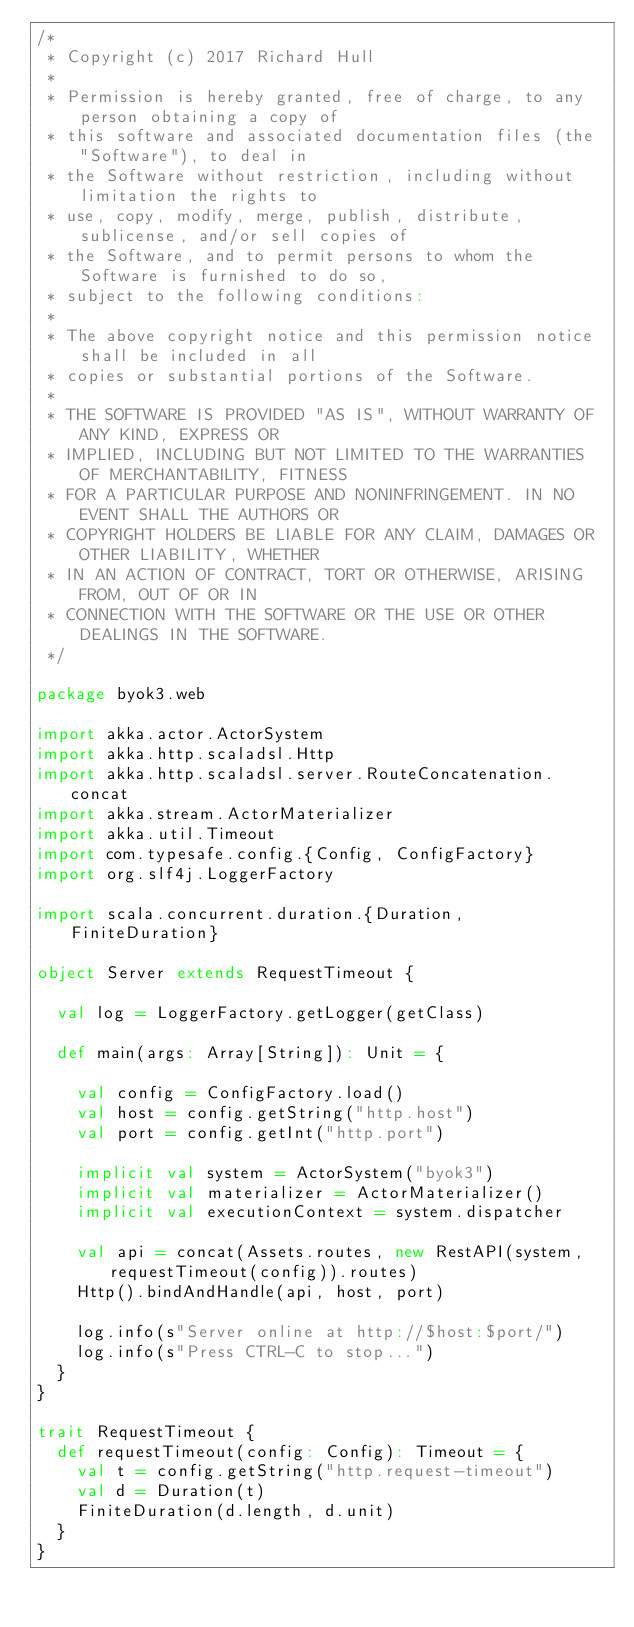Convert code to text. <code><loc_0><loc_0><loc_500><loc_500><_Scala_>/*
 * Copyright (c) 2017 Richard Hull
 *
 * Permission is hereby granted, free of charge, to any person obtaining a copy of
 * this software and associated documentation files (the "Software"), to deal in
 * the Software without restriction, including without limitation the rights to
 * use, copy, modify, merge, publish, distribute, sublicense, and/or sell copies of
 * the Software, and to permit persons to whom the Software is furnished to do so,
 * subject to the following conditions:
 *
 * The above copyright notice and this permission notice shall be included in all
 * copies or substantial portions of the Software.
 *
 * THE SOFTWARE IS PROVIDED "AS IS", WITHOUT WARRANTY OF ANY KIND, EXPRESS OR
 * IMPLIED, INCLUDING BUT NOT LIMITED TO THE WARRANTIES OF MERCHANTABILITY, FITNESS
 * FOR A PARTICULAR PURPOSE AND NONINFRINGEMENT. IN NO EVENT SHALL THE AUTHORS OR
 * COPYRIGHT HOLDERS BE LIABLE FOR ANY CLAIM, DAMAGES OR OTHER LIABILITY, WHETHER
 * IN AN ACTION OF CONTRACT, TORT OR OTHERWISE, ARISING FROM, OUT OF OR IN
 * CONNECTION WITH THE SOFTWARE OR THE USE OR OTHER DEALINGS IN THE SOFTWARE.
 */

package byok3.web

import akka.actor.ActorSystem
import akka.http.scaladsl.Http
import akka.http.scaladsl.server.RouteConcatenation.concat
import akka.stream.ActorMaterializer
import akka.util.Timeout
import com.typesafe.config.{Config, ConfigFactory}
import org.slf4j.LoggerFactory

import scala.concurrent.duration.{Duration, FiniteDuration}

object Server extends RequestTimeout {

  val log = LoggerFactory.getLogger(getClass)

  def main(args: Array[String]): Unit = {

    val config = ConfigFactory.load()
    val host = config.getString("http.host")
    val port = config.getInt("http.port")

    implicit val system = ActorSystem("byok3")
    implicit val materializer = ActorMaterializer()
    implicit val executionContext = system.dispatcher

    val api = concat(Assets.routes, new RestAPI(system, requestTimeout(config)).routes)
    Http().bindAndHandle(api, host, port)

    log.info(s"Server online at http://$host:$port/")
    log.info(s"Press CTRL-C to stop...")
  }
}

trait RequestTimeout {
  def requestTimeout(config: Config): Timeout = {
    val t = config.getString("http.request-timeout")
    val d = Duration(t)
    FiniteDuration(d.length, d.unit)
  }
}</code> 